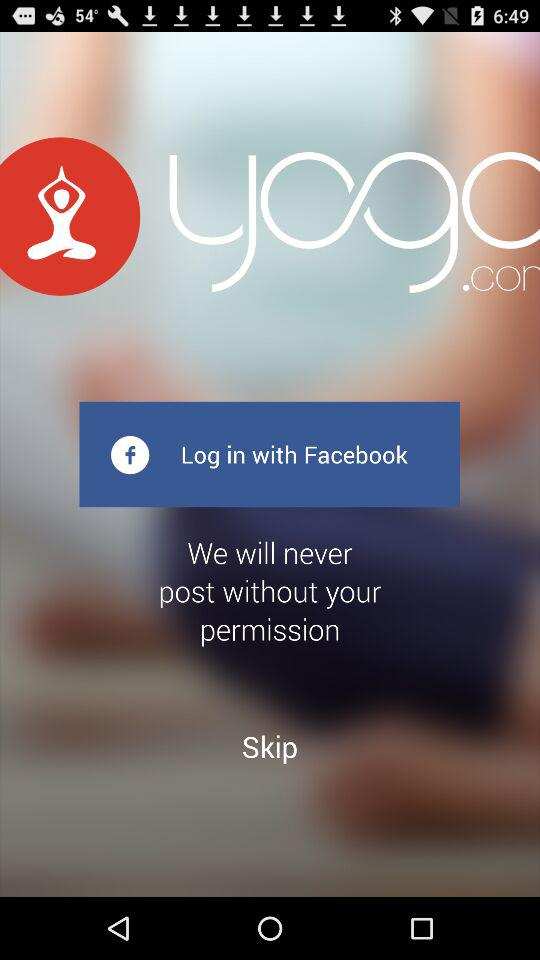What application can we log in with? You can log in with "Facebook". 